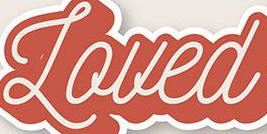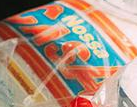Identify the words shown in these images in order, separated by a semicolon. Loued; CASA 